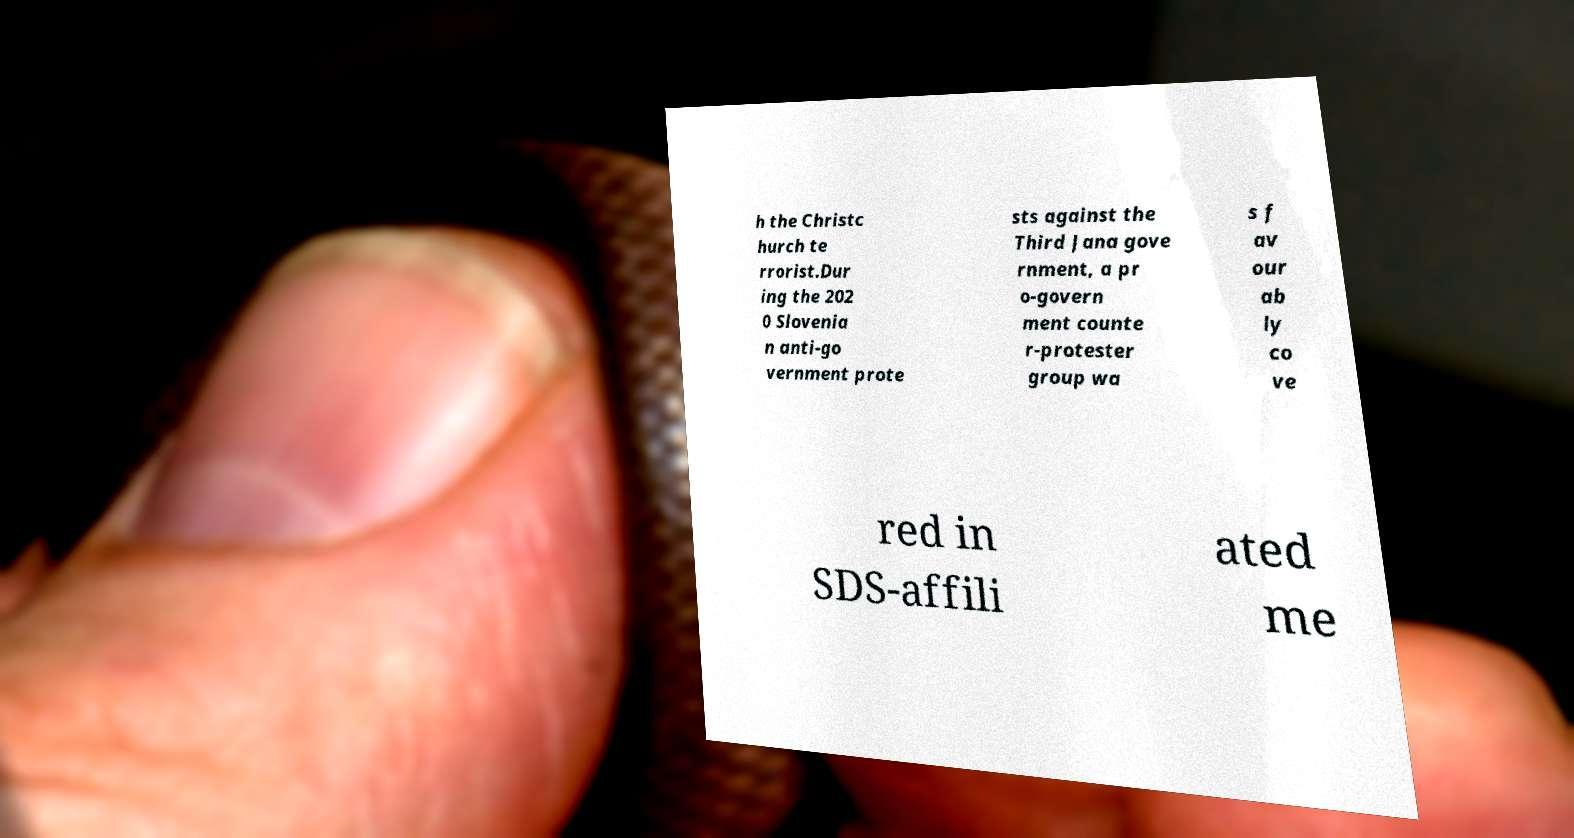What messages or text are displayed in this image? I need them in a readable, typed format. h the Christc hurch te rrorist.Dur ing the 202 0 Slovenia n anti-go vernment prote sts against the Third Jana gove rnment, a pr o-govern ment counte r-protester group wa s f av our ab ly co ve red in SDS-affili ated me 